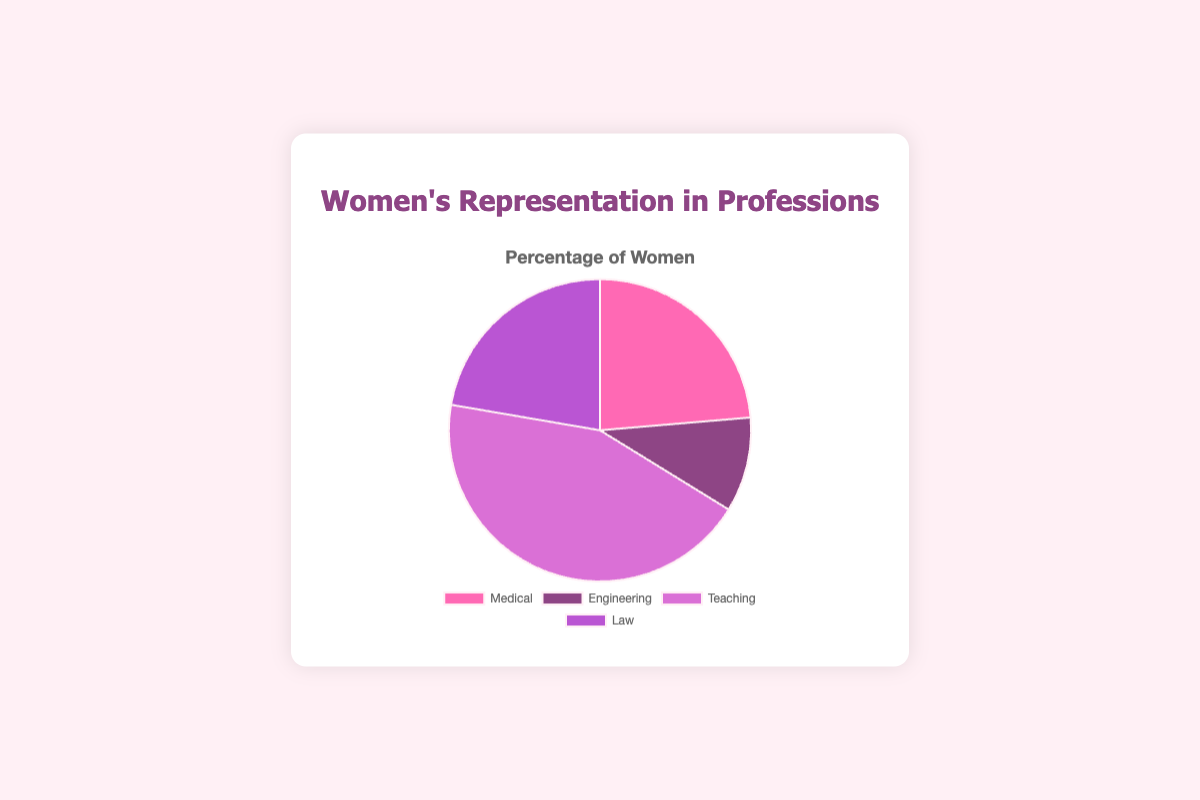Which profession has the highest representation of women? By looking at the pie chart, the profession section with the largest slice represents the highest percentage. Here, Teaching has 65%.
Answer: Teaching Which profession has the lowest representation of women? By examining the pie chart, the smallest slice corresponds to the lowest percentage. Here, Engineering has 15%.
Answer: Engineering What is the combined percentage of women's representation in Medical and Law professions? Add the percentages representing Medical and Law professions. Medical has 35% and Law has 33%, so 35 + 33 = 68%.
Answer: 68% Compare the representation of women in Medical and Teaching professions. Which one is higher and by how much percentage? Teaching has 65% while Medical has 35%. The difference is 65 - 35 = 30%. So, Teaching has a higher representation by 30%.
Answer: Teaching by 30% What is the average representation of women across all the professions shown? Sum the percentages and divide by the number of professions: (35 + 15 + 65 + 33) / 4 = 148 / 4 = 37%.
Answer: 37% What is the total percentage of women's representation in Engineering and Teaching combined? Add the percentages of Engineering 15% and Teaching 65%: 15 + 65 = 80%.
Answer: 80% Look at the colors in the pie chart. What color represents the Law profession? By referring to the color key in the pie chart and matching it to the segment for Law, it is represented by a purple-like color.
Answer: Purple Is the percentage of women in Teaching more than double that in Engineering? Compare double the percentage of Engineering to Teaching. Double of 15% is 30%, which is less than 65%. Hence, Teaching's percentage is more than double that of Engineering.
Answer: Yes What is the difference in percentage between the professions with the highest and lowest representation of women? Subtract the percentage of the lowest profession (Engineering, 15%) from the highest (Teaching, 65%): 65 - 15 = 50%.
Answer: 50% If we combine the representation percentages of Medical and Law, does their sum exceed the percentage of women in Teaching? Combine the percentages of Medical (35%) and Law (33%), which equal 68%. Compare this to Teaching's 65%. Since 68% is greater than 65%, the sum exceeds Teaching's percentage.
Answer: Yes 